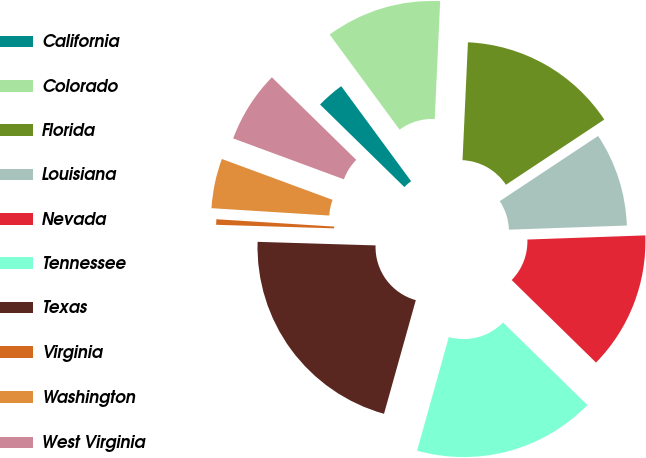Convert chart to OTSL. <chart><loc_0><loc_0><loc_500><loc_500><pie_chart><fcel>California<fcel>Colorado<fcel>Florida<fcel>Louisiana<fcel>Nevada<fcel>Tennessee<fcel>Texas<fcel>Virginia<fcel>Washington<fcel>West Virginia<nl><fcel>2.58%<fcel>10.82%<fcel>14.95%<fcel>8.76%<fcel>12.89%<fcel>17.01%<fcel>21.14%<fcel>0.51%<fcel>4.64%<fcel>6.7%<nl></chart> 